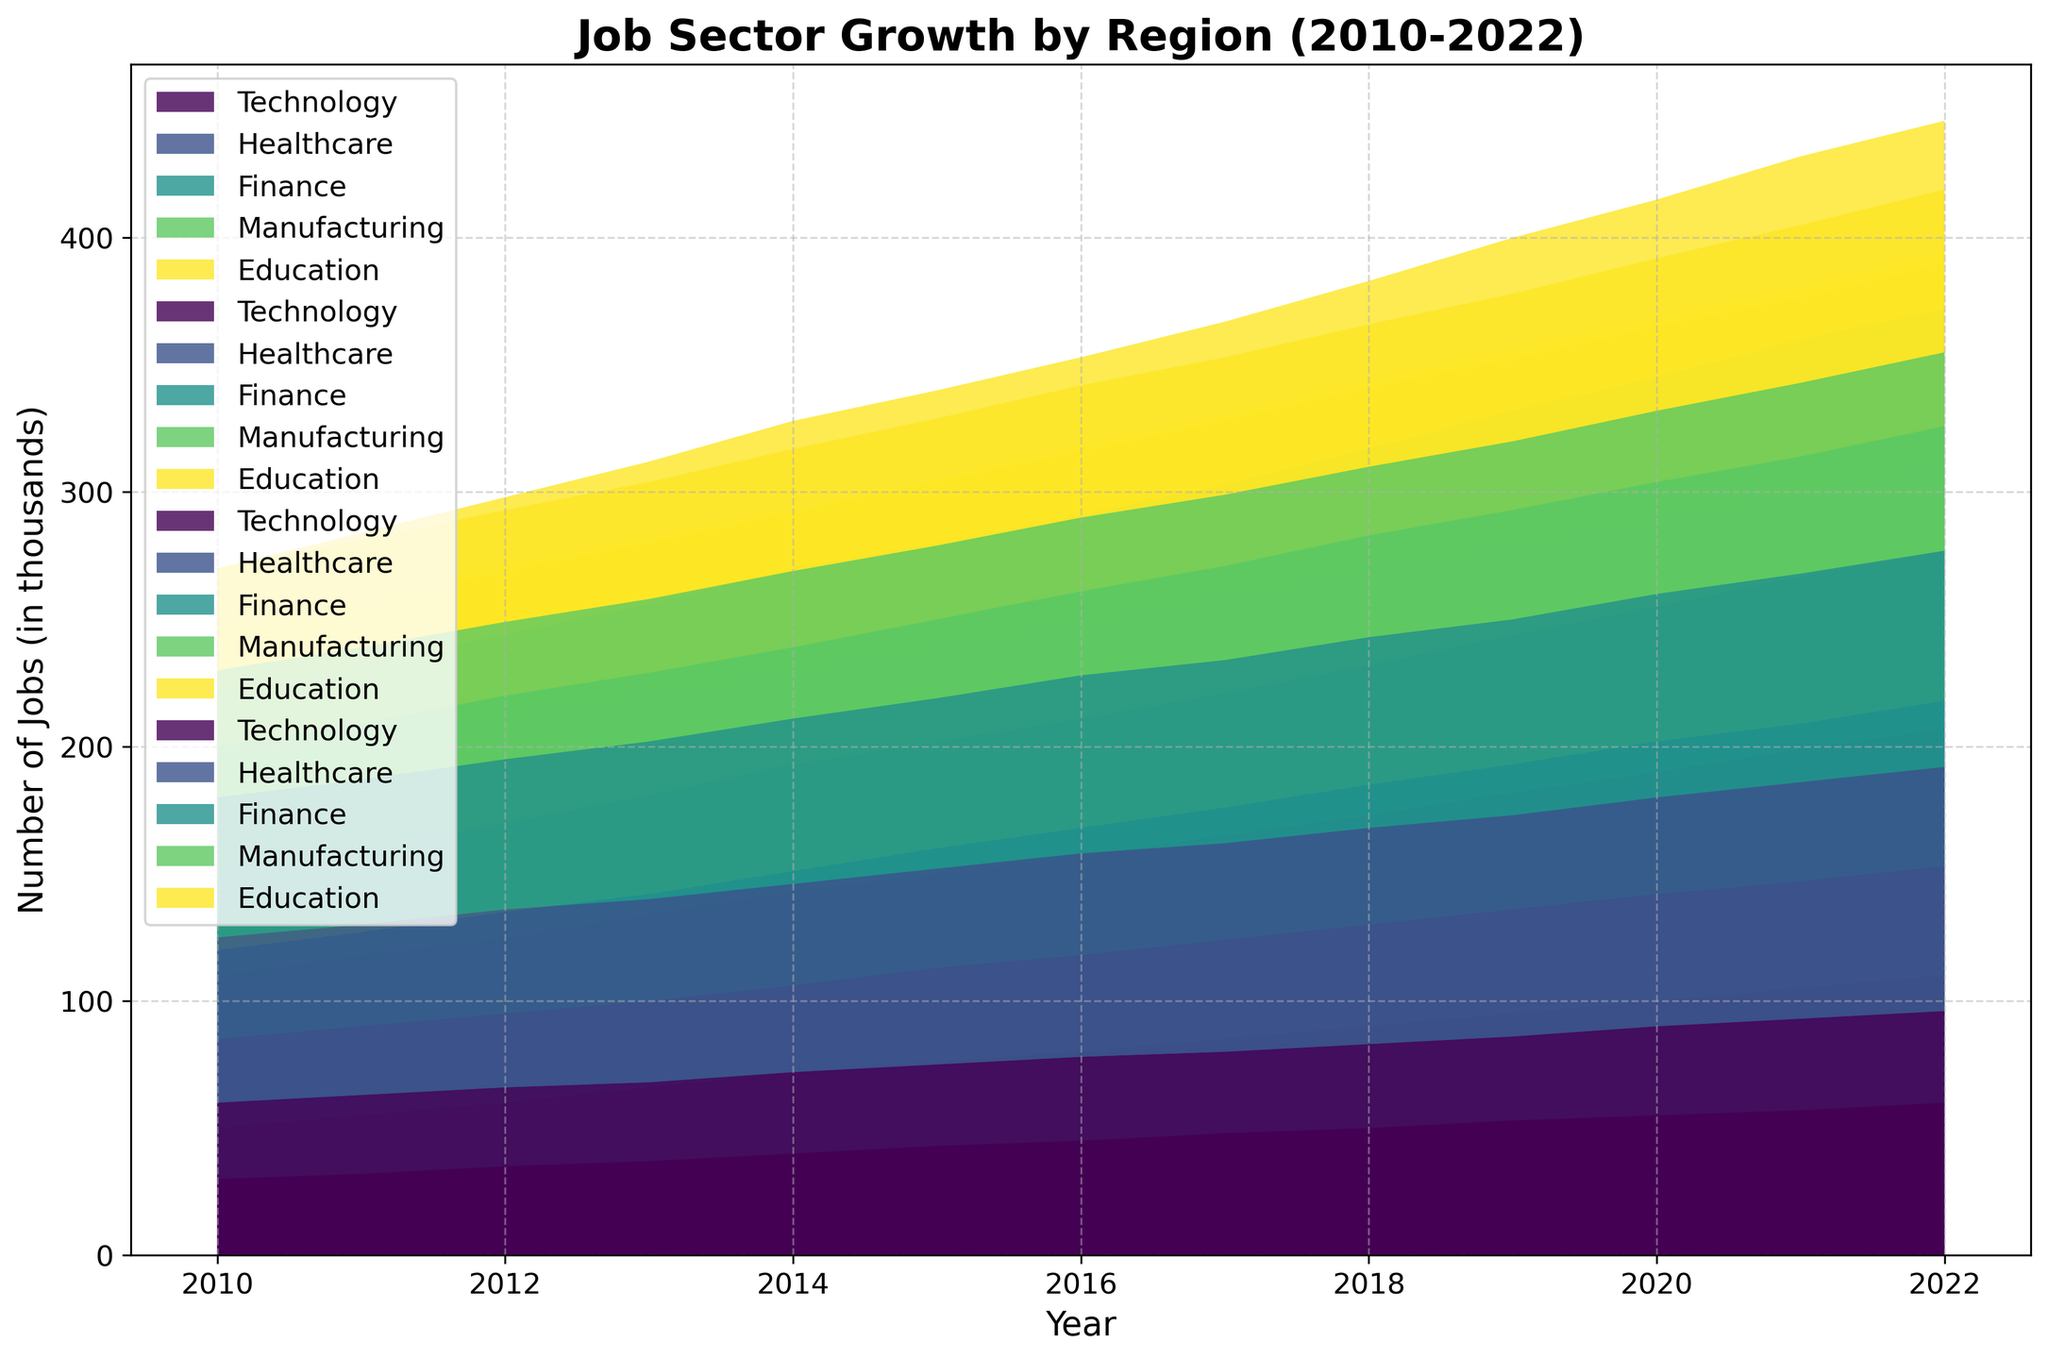Which job sector has shown the greatest growth in the Northeast region over the past decade? By visually inspecting the plot for the Northeast region, observe the area chart's slope for each job sector. The Technology sector shows the steepest increase from about 50 in 2010 to 110 in 2022.
Answer: Technology How does the growth of the Finance sector in the South compare to that in the West? By comparing the heights of the Finance sector areas in both regions over time, Finance in the South starts at 35 in 2010 and reaches 65 in 2022, while in the West, it starts at 55 in 2010 and reaches 85 in 2022. The growth is greater in the West.
Answer: Greater in the West Which region experienced the most consistent growth in the Manufacturing sector? Consistency can be assessed by looking for smooth, steady increases over time. The South region shows a steady rise from 80 in 2010 to 108 in 2022.
Answer: South What is the combined number of jobs in Technology and Healthcare sectors in the Midwest in 2020? Sum the values for Technology (62) and Healthcare (75) in the Midwest for 2020. 62 + 75 = 137.
Answer: 137 How did the Education sector's growth in the West compare to other regions? Assess the relative increase in the area representing the Education sector in the West against other regions. The West saw an increase from 40 in 2010 to 64 in 2022, which is more modest compared to other regions like the Northeast.
Answer: Less growth in the West Between 2015 and 2017, which sector experienced the greatest growth in the Northeast? Compare the areas' heights for different job sectors between 2015 and 2017. The Technology sector grew from 76 to 85, which is the greatest change.
Answer: Technology Which region had the smallest increase in the Healthcare sector over the last decade? By estimating the slopes of the different Healthcare areas across all regions, the Midwest has the smallest difference, increasing from 50 in 2010 to 80 in 2022.
Answer: Midwest What is the difference in the number of jobs in the Manufacturing sector between the South and Midwest in 2022? Subtract the Midwest value (88) from the South value (108) for the Manufacturing sector in 2022. The difference is 108 - 88 = 20.
Answer: 20 Among all regions, which had the highest number of jobs in the Education sector in 2022? By comparing the top values of the Education areas for 2022 across regions, the Northeast has the highest value at 74.
Answer: Northeast 